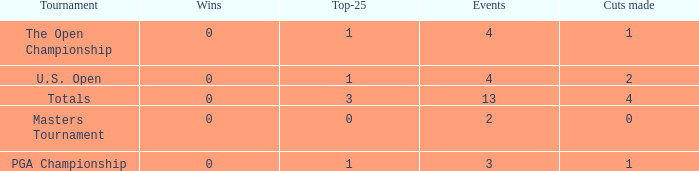How many cuts did he make in the tournament with 3 top 25s and under 13 events? None. 